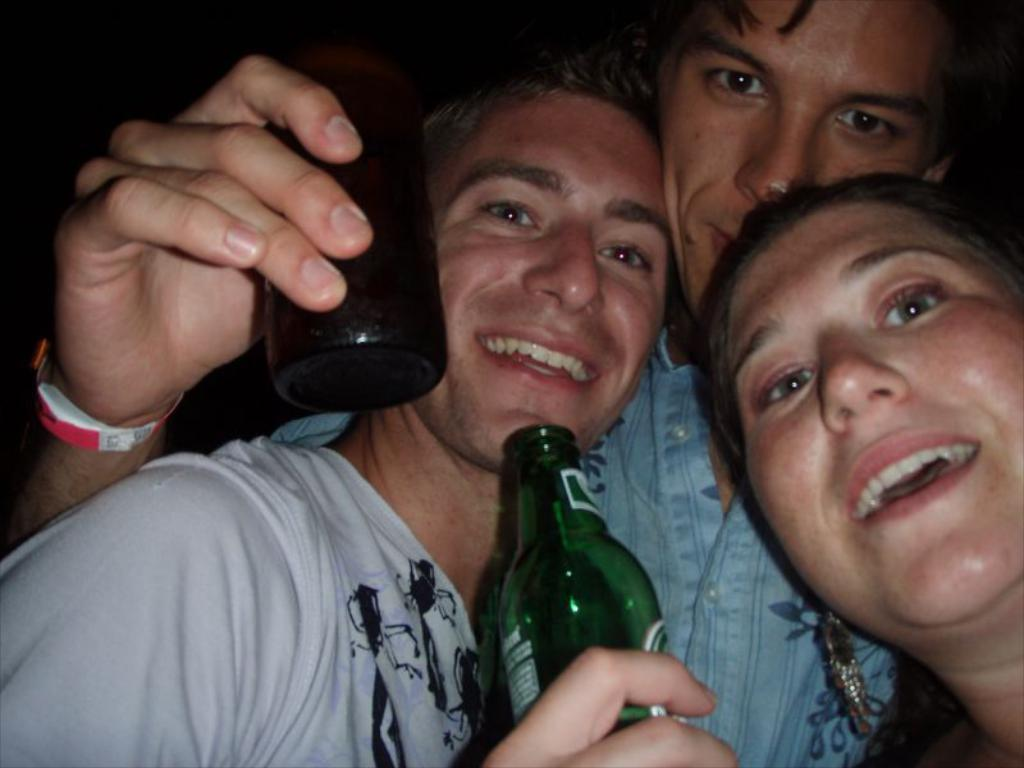How many people are in the image? There are three persons in the image. What is the facial expression of the persons in the image? The persons are smiling. What are the persons holding in their hands? The persons are holding bottles in their hands. What type of toys can be seen in the hands of the persons in the image? There are no toys present in the image; the persons are holding bottles. 